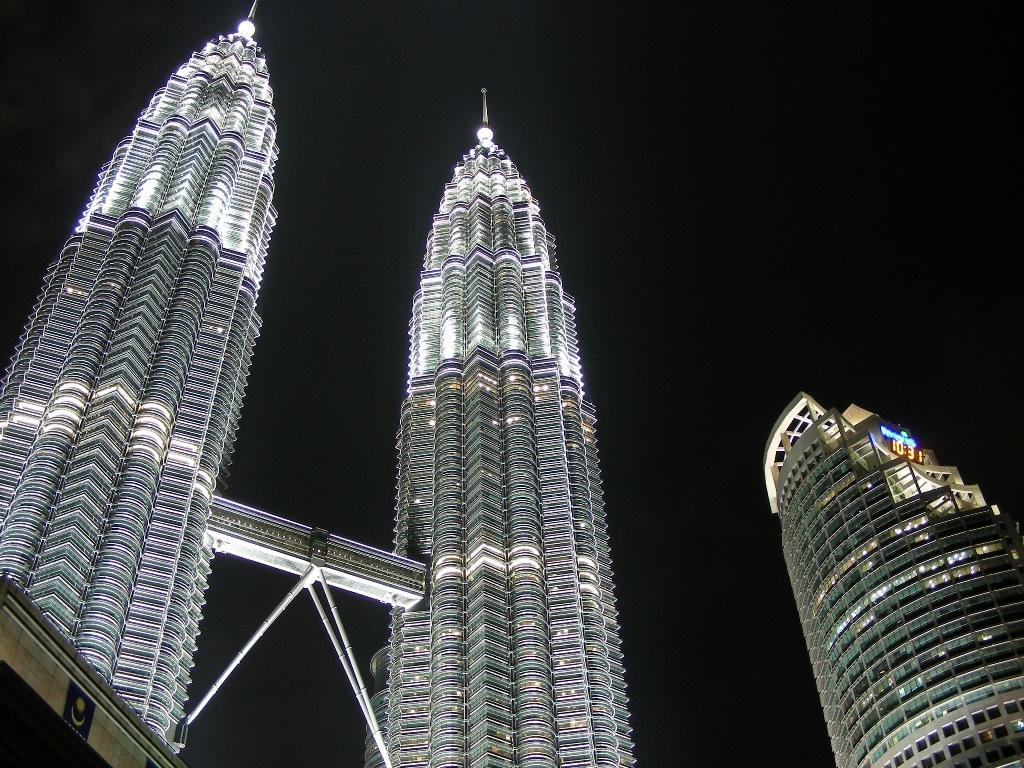What type of structures are visible in the image? There are skyscrapers and a building in the image. Can you describe the background of the image? The background of the image is dark. Where is the girl playing on the playground in the image? There is no girl or playground present in the image. 